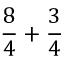Convert formula to latex. <formula><loc_0><loc_0><loc_500><loc_500>{ \frac { 8 } { 4 } } + { \frac { 3 } { 4 } }</formula> 